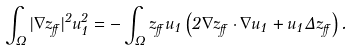Convert formula to latex. <formula><loc_0><loc_0><loc_500><loc_500>\int _ { \Omega } | \nabla z _ { \alpha } | ^ { 2 } u _ { 1 } ^ { 2 } = - \int _ { \Omega } z _ { \alpha } u _ { 1 } \left ( 2 \nabla z _ { \alpha } \cdot \nabla u _ { 1 } + u _ { 1 } \Delta z _ { \alpha } \right ) .</formula> 